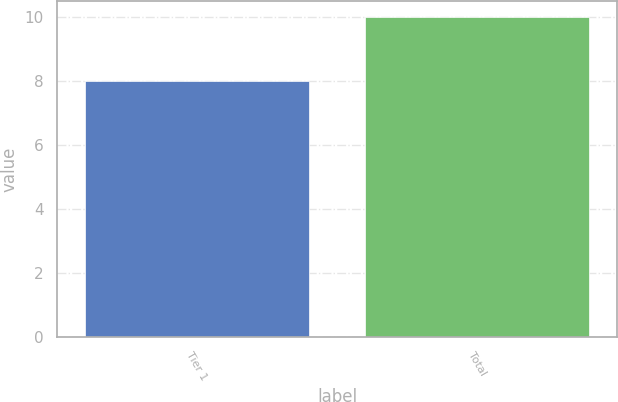Convert chart. <chart><loc_0><loc_0><loc_500><loc_500><bar_chart><fcel>Tier 1<fcel>Total<nl><fcel>8<fcel>10<nl></chart> 